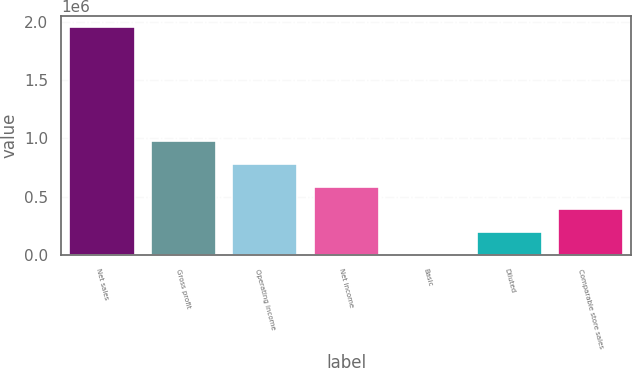<chart> <loc_0><loc_0><loc_500><loc_500><bar_chart><fcel>Net sales<fcel>Gross profit<fcel>Operating income<fcel>Net income<fcel>Basic<fcel>Diluted<fcel>Comparable store sales<nl><fcel>1.95284e+06<fcel>976419<fcel>781136<fcel>585852<fcel>0.87<fcel>195285<fcel>390568<nl></chart> 